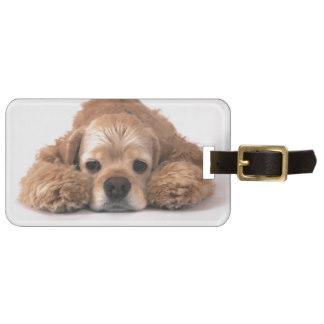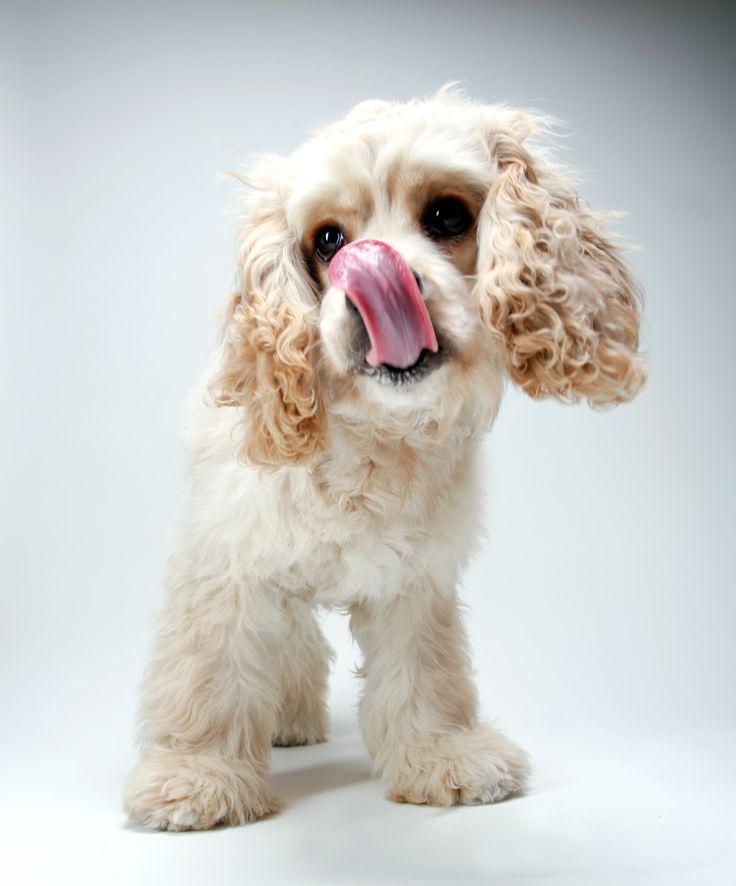The first image is the image on the left, the second image is the image on the right. Evaluate the accuracy of this statement regarding the images: "There is a total of 1 or more dogs whose bodies are facing right.". Is it true? Answer yes or no. No. The first image is the image on the left, the second image is the image on the right. For the images displayed, is the sentence "a dog is wearing a coat strapped under it's belly" factually correct? Answer yes or no. No. 